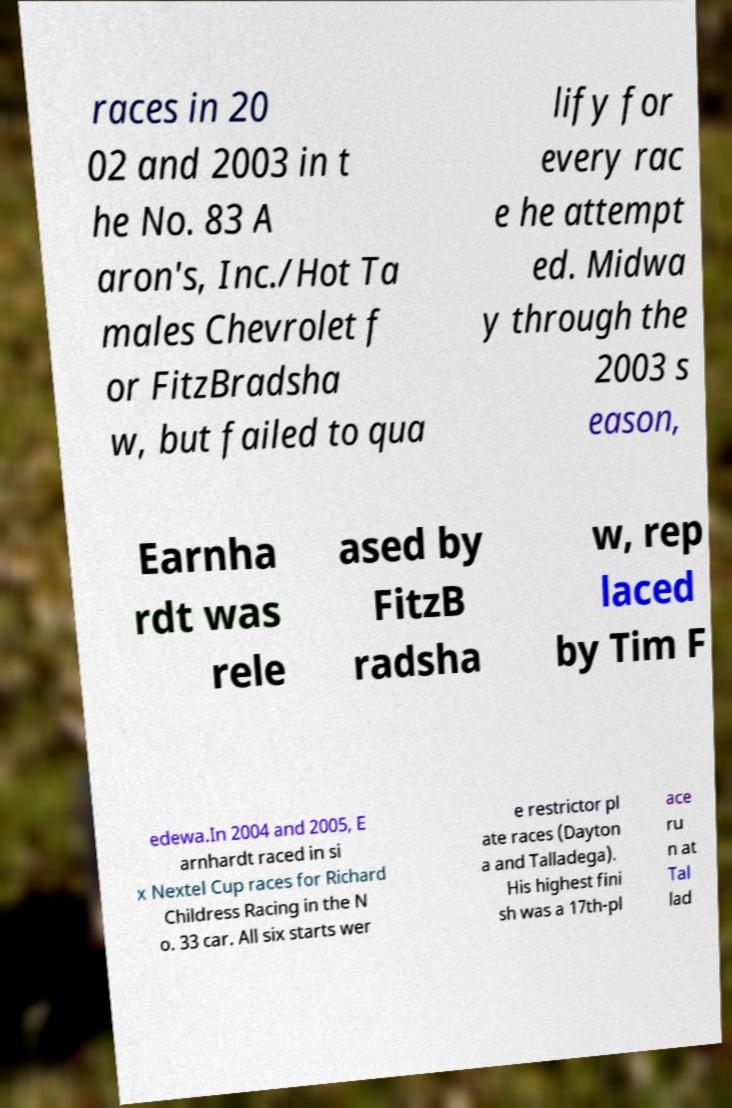For documentation purposes, I need the text within this image transcribed. Could you provide that? races in 20 02 and 2003 in t he No. 83 A aron's, Inc./Hot Ta males Chevrolet f or FitzBradsha w, but failed to qua lify for every rac e he attempt ed. Midwa y through the 2003 s eason, Earnha rdt was rele ased by FitzB radsha w, rep laced by Tim F edewa.In 2004 and 2005, E arnhardt raced in si x Nextel Cup races for Richard Childress Racing in the N o. 33 car. All six starts wer e restrictor pl ate races (Dayton a and Talladega). His highest fini sh was a 17th-pl ace ru n at Tal lad 